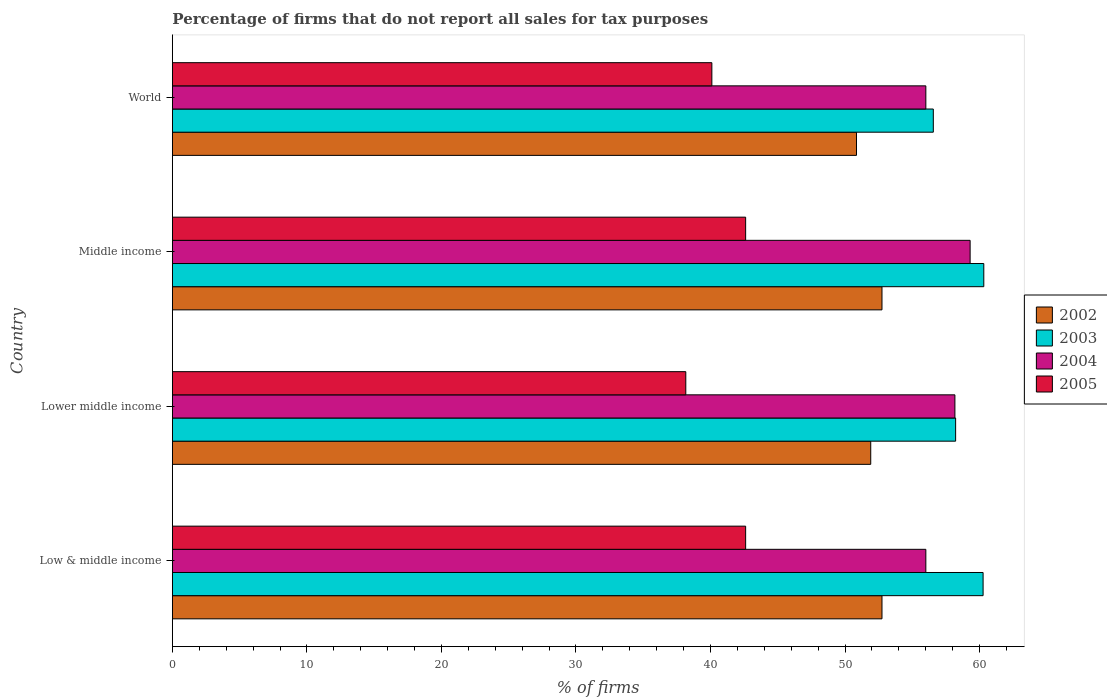How many different coloured bars are there?
Give a very brief answer. 4. How many groups of bars are there?
Offer a very short reply. 4. How many bars are there on the 3rd tick from the top?
Give a very brief answer. 4. What is the label of the 1st group of bars from the top?
Your response must be concise. World. What is the percentage of firms that do not report all sales for tax purposes in 2002 in World?
Provide a succinct answer. 50.85. Across all countries, what is the maximum percentage of firms that do not report all sales for tax purposes in 2005?
Offer a very short reply. 42.61. Across all countries, what is the minimum percentage of firms that do not report all sales for tax purposes in 2004?
Provide a short and direct response. 56.01. In which country was the percentage of firms that do not report all sales for tax purposes in 2003 minimum?
Give a very brief answer. World. What is the total percentage of firms that do not report all sales for tax purposes in 2002 in the graph?
Your answer should be compact. 208.25. What is the difference between the percentage of firms that do not report all sales for tax purposes in 2003 in Low & middle income and that in World?
Provide a succinct answer. 3.7. What is the difference between the percentage of firms that do not report all sales for tax purposes in 2004 in Lower middle income and the percentage of firms that do not report all sales for tax purposes in 2002 in Middle income?
Ensure brevity in your answer.  5.42. What is the average percentage of firms that do not report all sales for tax purposes in 2005 per country?
Your response must be concise. 40.87. What is the difference between the percentage of firms that do not report all sales for tax purposes in 2005 and percentage of firms that do not report all sales for tax purposes in 2004 in Middle income?
Offer a terse response. -16.69. In how many countries, is the percentage of firms that do not report all sales for tax purposes in 2004 greater than 32 %?
Your answer should be very brief. 4. What is the ratio of the percentage of firms that do not report all sales for tax purposes in 2004 in Low & middle income to that in Lower middle income?
Provide a succinct answer. 0.96. Is the percentage of firms that do not report all sales for tax purposes in 2004 in Low & middle income less than that in Lower middle income?
Provide a succinct answer. Yes. What is the difference between the highest and the second highest percentage of firms that do not report all sales for tax purposes in 2003?
Your answer should be compact. 0.05. What is the difference between the highest and the lowest percentage of firms that do not report all sales for tax purposes in 2003?
Provide a succinct answer. 3.75. What does the 4th bar from the top in World represents?
Your response must be concise. 2002. How many countries are there in the graph?
Your answer should be very brief. 4. Are the values on the major ticks of X-axis written in scientific E-notation?
Keep it short and to the point. No. Does the graph contain any zero values?
Give a very brief answer. No. Where does the legend appear in the graph?
Your answer should be very brief. Center right. What is the title of the graph?
Ensure brevity in your answer.  Percentage of firms that do not report all sales for tax purposes. What is the label or title of the X-axis?
Offer a very short reply. % of firms. What is the % of firms of 2002 in Low & middle income?
Keep it short and to the point. 52.75. What is the % of firms of 2003 in Low & middle income?
Offer a terse response. 60.26. What is the % of firms of 2004 in Low & middle income?
Your response must be concise. 56.01. What is the % of firms in 2005 in Low & middle income?
Keep it short and to the point. 42.61. What is the % of firms of 2002 in Lower middle income?
Your answer should be compact. 51.91. What is the % of firms in 2003 in Lower middle income?
Provide a succinct answer. 58.22. What is the % of firms of 2004 in Lower middle income?
Your response must be concise. 58.16. What is the % of firms in 2005 in Lower middle income?
Provide a succinct answer. 38.16. What is the % of firms of 2002 in Middle income?
Your response must be concise. 52.75. What is the % of firms in 2003 in Middle income?
Make the answer very short. 60.31. What is the % of firms in 2004 in Middle income?
Make the answer very short. 59.3. What is the % of firms in 2005 in Middle income?
Offer a terse response. 42.61. What is the % of firms of 2002 in World?
Make the answer very short. 50.85. What is the % of firms of 2003 in World?
Give a very brief answer. 56.56. What is the % of firms of 2004 in World?
Keep it short and to the point. 56.01. What is the % of firms of 2005 in World?
Your response must be concise. 40.1. Across all countries, what is the maximum % of firms of 2002?
Provide a short and direct response. 52.75. Across all countries, what is the maximum % of firms in 2003?
Provide a short and direct response. 60.31. Across all countries, what is the maximum % of firms in 2004?
Provide a short and direct response. 59.3. Across all countries, what is the maximum % of firms of 2005?
Ensure brevity in your answer.  42.61. Across all countries, what is the minimum % of firms in 2002?
Make the answer very short. 50.85. Across all countries, what is the minimum % of firms in 2003?
Keep it short and to the point. 56.56. Across all countries, what is the minimum % of firms of 2004?
Keep it short and to the point. 56.01. Across all countries, what is the minimum % of firms of 2005?
Give a very brief answer. 38.16. What is the total % of firms of 2002 in the graph?
Keep it short and to the point. 208.25. What is the total % of firms of 2003 in the graph?
Provide a short and direct response. 235.35. What is the total % of firms in 2004 in the graph?
Ensure brevity in your answer.  229.47. What is the total % of firms in 2005 in the graph?
Keep it short and to the point. 163.48. What is the difference between the % of firms in 2002 in Low & middle income and that in Lower middle income?
Keep it short and to the point. 0.84. What is the difference between the % of firms of 2003 in Low & middle income and that in Lower middle income?
Give a very brief answer. 2.04. What is the difference between the % of firms in 2004 in Low & middle income and that in Lower middle income?
Make the answer very short. -2.16. What is the difference between the % of firms in 2005 in Low & middle income and that in Lower middle income?
Your answer should be very brief. 4.45. What is the difference between the % of firms in 2002 in Low & middle income and that in Middle income?
Your answer should be compact. 0. What is the difference between the % of firms in 2003 in Low & middle income and that in Middle income?
Provide a succinct answer. -0.05. What is the difference between the % of firms of 2004 in Low & middle income and that in Middle income?
Offer a terse response. -3.29. What is the difference between the % of firms in 2005 in Low & middle income and that in Middle income?
Your response must be concise. 0. What is the difference between the % of firms of 2002 in Low & middle income and that in World?
Give a very brief answer. 1.89. What is the difference between the % of firms in 2004 in Low & middle income and that in World?
Provide a short and direct response. 0. What is the difference between the % of firms in 2005 in Low & middle income and that in World?
Ensure brevity in your answer.  2.51. What is the difference between the % of firms of 2002 in Lower middle income and that in Middle income?
Ensure brevity in your answer.  -0.84. What is the difference between the % of firms in 2003 in Lower middle income and that in Middle income?
Give a very brief answer. -2.09. What is the difference between the % of firms in 2004 in Lower middle income and that in Middle income?
Provide a short and direct response. -1.13. What is the difference between the % of firms in 2005 in Lower middle income and that in Middle income?
Offer a terse response. -4.45. What is the difference between the % of firms in 2002 in Lower middle income and that in World?
Provide a short and direct response. 1.06. What is the difference between the % of firms in 2003 in Lower middle income and that in World?
Make the answer very short. 1.66. What is the difference between the % of firms in 2004 in Lower middle income and that in World?
Offer a terse response. 2.16. What is the difference between the % of firms of 2005 in Lower middle income and that in World?
Your answer should be very brief. -1.94. What is the difference between the % of firms in 2002 in Middle income and that in World?
Offer a very short reply. 1.89. What is the difference between the % of firms of 2003 in Middle income and that in World?
Your response must be concise. 3.75. What is the difference between the % of firms of 2004 in Middle income and that in World?
Provide a short and direct response. 3.29. What is the difference between the % of firms in 2005 in Middle income and that in World?
Provide a short and direct response. 2.51. What is the difference between the % of firms in 2002 in Low & middle income and the % of firms in 2003 in Lower middle income?
Offer a very short reply. -5.47. What is the difference between the % of firms of 2002 in Low & middle income and the % of firms of 2004 in Lower middle income?
Your response must be concise. -5.42. What is the difference between the % of firms in 2002 in Low & middle income and the % of firms in 2005 in Lower middle income?
Make the answer very short. 14.58. What is the difference between the % of firms of 2003 in Low & middle income and the % of firms of 2004 in Lower middle income?
Make the answer very short. 2.1. What is the difference between the % of firms in 2003 in Low & middle income and the % of firms in 2005 in Lower middle income?
Your answer should be compact. 22.1. What is the difference between the % of firms of 2004 in Low & middle income and the % of firms of 2005 in Lower middle income?
Your response must be concise. 17.84. What is the difference between the % of firms of 2002 in Low & middle income and the % of firms of 2003 in Middle income?
Offer a very short reply. -7.57. What is the difference between the % of firms of 2002 in Low & middle income and the % of firms of 2004 in Middle income?
Make the answer very short. -6.55. What is the difference between the % of firms of 2002 in Low & middle income and the % of firms of 2005 in Middle income?
Provide a short and direct response. 10.13. What is the difference between the % of firms of 2003 in Low & middle income and the % of firms of 2005 in Middle income?
Your response must be concise. 17.65. What is the difference between the % of firms in 2004 in Low & middle income and the % of firms in 2005 in Middle income?
Provide a succinct answer. 13.39. What is the difference between the % of firms of 2002 in Low & middle income and the % of firms of 2003 in World?
Your response must be concise. -3.81. What is the difference between the % of firms in 2002 in Low & middle income and the % of firms in 2004 in World?
Ensure brevity in your answer.  -3.26. What is the difference between the % of firms in 2002 in Low & middle income and the % of firms in 2005 in World?
Keep it short and to the point. 12.65. What is the difference between the % of firms in 2003 in Low & middle income and the % of firms in 2004 in World?
Give a very brief answer. 4.25. What is the difference between the % of firms in 2003 in Low & middle income and the % of firms in 2005 in World?
Ensure brevity in your answer.  20.16. What is the difference between the % of firms of 2004 in Low & middle income and the % of firms of 2005 in World?
Offer a terse response. 15.91. What is the difference between the % of firms in 2002 in Lower middle income and the % of firms in 2003 in Middle income?
Offer a terse response. -8.4. What is the difference between the % of firms in 2002 in Lower middle income and the % of firms in 2004 in Middle income?
Offer a terse response. -7.39. What is the difference between the % of firms of 2002 in Lower middle income and the % of firms of 2005 in Middle income?
Your answer should be compact. 9.3. What is the difference between the % of firms in 2003 in Lower middle income and the % of firms in 2004 in Middle income?
Offer a terse response. -1.08. What is the difference between the % of firms in 2003 in Lower middle income and the % of firms in 2005 in Middle income?
Keep it short and to the point. 15.61. What is the difference between the % of firms of 2004 in Lower middle income and the % of firms of 2005 in Middle income?
Offer a terse response. 15.55. What is the difference between the % of firms of 2002 in Lower middle income and the % of firms of 2003 in World?
Provide a short and direct response. -4.65. What is the difference between the % of firms in 2002 in Lower middle income and the % of firms in 2004 in World?
Provide a succinct answer. -4.1. What is the difference between the % of firms of 2002 in Lower middle income and the % of firms of 2005 in World?
Offer a terse response. 11.81. What is the difference between the % of firms in 2003 in Lower middle income and the % of firms in 2004 in World?
Your answer should be compact. 2.21. What is the difference between the % of firms in 2003 in Lower middle income and the % of firms in 2005 in World?
Give a very brief answer. 18.12. What is the difference between the % of firms in 2004 in Lower middle income and the % of firms in 2005 in World?
Your answer should be compact. 18.07. What is the difference between the % of firms in 2002 in Middle income and the % of firms in 2003 in World?
Make the answer very short. -3.81. What is the difference between the % of firms of 2002 in Middle income and the % of firms of 2004 in World?
Your answer should be very brief. -3.26. What is the difference between the % of firms of 2002 in Middle income and the % of firms of 2005 in World?
Your answer should be compact. 12.65. What is the difference between the % of firms in 2003 in Middle income and the % of firms in 2004 in World?
Provide a short and direct response. 4.31. What is the difference between the % of firms of 2003 in Middle income and the % of firms of 2005 in World?
Make the answer very short. 20.21. What is the difference between the % of firms in 2004 in Middle income and the % of firms in 2005 in World?
Provide a short and direct response. 19.2. What is the average % of firms in 2002 per country?
Give a very brief answer. 52.06. What is the average % of firms in 2003 per country?
Offer a terse response. 58.84. What is the average % of firms in 2004 per country?
Keep it short and to the point. 57.37. What is the average % of firms in 2005 per country?
Ensure brevity in your answer.  40.87. What is the difference between the % of firms in 2002 and % of firms in 2003 in Low & middle income?
Give a very brief answer. -7.51. What is the difference between the % of firms in 2002 and % of firms in 2004 in Low & middle income?
Provide a succinct answer. -3.26. What is the difference between the % of firms of 2002 and % of firms of 2005 in Low & middle income?
Give a very brief answer. 10.13. What is the difference between the % of firms in 2003 and % of firms in 2004 in Low & middle income?
Your answer should be very brief. 4.25. What is the difference between the % of firms of 2003 and % of firms of 2005 in Low & middle income?
Offer a terse response. 17.65. What is the difference between the % of firms of 2004 and % of firms of 2005 in Low & middle income?
Provide a short and direct response. 13.39. What is the difference between the % of firms in 2002 and % of firms in 2003 in Lower middle income?
Ensure brevity in your answer.  -6.31. What is the difference between the % of firms of 2002 and % of firms of 2004 in Lower middle income?
Your answer should be very brief. -6.26. What is the difference between the % of firms of 2002 and % of firms of 2005 in Lower middle income?
Offer a very short reply. 13.75. What is the difference between the % of firms of 2003 and % of firms of 2004 in Lower middle income?
Offer a terse response. 0.05. What is the difference between the % of firms in 2003 and % of firms in 2005 in Lower middle income?
Ensure brevity in your answer.  20.06. What is the difference between the % of firms of 2004 and % of firms of 2005 in Lower middle income?
Your answer should be compact. 20. What is the difference between the % of firms in 2002 and % of firms in 2003 in Middle income?
Provide a short and direct response. -7.57. What is the difference between the % of firms in 2002 and % of firms in 2004 in Middle income?
Make the answer very short. -6.55. What is the difference between the % of firms of 2002 and % of firms of 2005 in Middle income?
Provide a succinct answer. 10.13. What is the difference between the % of firms of 2003 and % of firms of 2004 in Middle income?
Your answer should be compact. 1.02. What is the difference between the % of firms in 2003 and % of firms in 2005 in Middle income?
Your answer should be very brief. 17.7. What is the difference between the % of firms of 2004 and % of firms of 2005 in Middle income?
Your answer should be compact. 16.69. What is the difference between the % of firms in 2002 and % of firms in 2003 in World?
Ensure brevity in your answer.  -5.71. What is the difference between the % of firms in 2002 and % of firms in 2004 in World?
Offer a very short reply. -5.15. What is the difference between the % of firms in 2002 and % of firms in 2005 in World?
Keep it short and to the point. 10.75. What is the difference between the % of firms of 2003 and % of firms of 2004 in World?
Provide a short and direct response. 0.56. What is the difference between the % of firms in 2003 and % of firms in 2005 in World?
Ensure brevity in your answer.  16.46. What is the difference between the % of firms of 2004 and % of firms of 2005 in World?
Provide a succinct answer. 15.91. What is the ratio of the % of firms in 2002 in Low & middle income to that in Lower middle income?
Provide a short and direct response. 1.02. What is the ratio of the % of firms of 2003 in Low & middle income to that in Lower middle income?
Your answer should be compact. 1.04. What is the ratio of the % of firms in 2004 in Low & middle income to that in Lower middle income?
Provide a succinct answer. 0.96. What is the ratio of the % of firms of 2005 in Low & middle income to that in Lower middle income?
Your answer should be very brief. 1.12. What is the ratio of the % of firms of 2003 in Low & middle income to that in Middle income?
Your response must be concise. 1. What is the ratio of the % of firms in 2004 in Low & middle income to that in Middle income?
Your answer should be very brief. 0.94. What is the ratio of the % of firms of 2005 in Low & middle income to that in Middle income?
Offer a very short reply. 1. What is the ratio of the % of firms of 2002 in Low & middle income to that in World?
Your response must be concise. 1.04. What is the ratio of the % of firms of 2003 in Low & middle income to that in World?
Your answer should be compact. 1.07. What is the ratio of the % of firms in 2004 in Low & middle income to that in World?
Offer a very short reply. 1. What is the ratio of the % of firms in 2005 in Low & middle income to that in World?
Your answer should be very brief. 1.06. What is the ratio of the % of firms in 2002 in Lower middle income to that in Middle income?
Ensure brevity in your answer.  0.98. What is the ratio of the % of firms in 2003 in Lower middle income to that in Middle income?
Offer a very short reply. 0.97. What is the ratio of the % of firms of 2004 in Lower middle income to that in Middle income?
Your answer should be compact. 0.98. What is the ratio of the % of firms of 2005 in Lower middle income to that in Middle income?
Your answer should be compact. 0.9. What is the ratio of the % of firms in 2002 in Lower middle income to that in World?
Your answer should be very brief. 1.02. What is the ratio of the % of firms in 2003 in Lower middle income to that in World?
Offer a terse response. 1.03. What is the ratio of the % of firms of 2004 in Lower middle income to that in World?
Offer a terse response. 1.04. What is the ratio of the % of firms in 2005 in Lower middle income to that in World?
Your answer should be very brief. 0.95. What is the ratio of the % of firms of 2002 in Middle income to that in World?
Provide a short and direct response. 1.04. What is the ratio of the % of firms in 2003 in Middle income to that in World?
Your answer should be compact. 1.07. What is the ratio of the % of firms of 2004 in Middle income to that in World?
Your response must be concise. 1.06. What is the ratio of the % of firms of 2005 in Middle income to that in World?
Your answer should be compact. 1.06. What is the difference between the highest and the second highest % of firms of 2002?
Your response must be concise. 0. What is the difference between the highest and the second highest % of firms in 2003?
Provide a short and direct response. 0.05. What is the difference between the highest and the second highest % of firms in 2004?
Provide a succinct answer. 1.13. What is the difference between the highest and the lowest % of firms of 2002?
Provide a short and direct response. 1.89. What is the difference between the highest and the lowest % of firms of 2003?
Your answer should be compact. 3.75. What is the difference between the highest and the lowest % of firms in 2004?
Provide a short and direct response. 3.29. What is the difference between the highest and the lowest % of firms in 2005?
Ensure brevity in your answer.  4.45. 